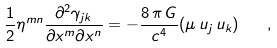Convert formula to latex. <formula><loc_0><loc_0><loc_500><loc_500>\frac { 1 } { 2 } \eta ^ { m n } \frac { \partial ^ { 2 } \gamma _ { j k } } { \partial x ^ { m } \partial x ^ { n } } = - \frac { 8 \, \pi \, G } { c ^ { 4 } } ( \mu \, u _ { j } \, u _ { k } ) \quad ,</formula> 